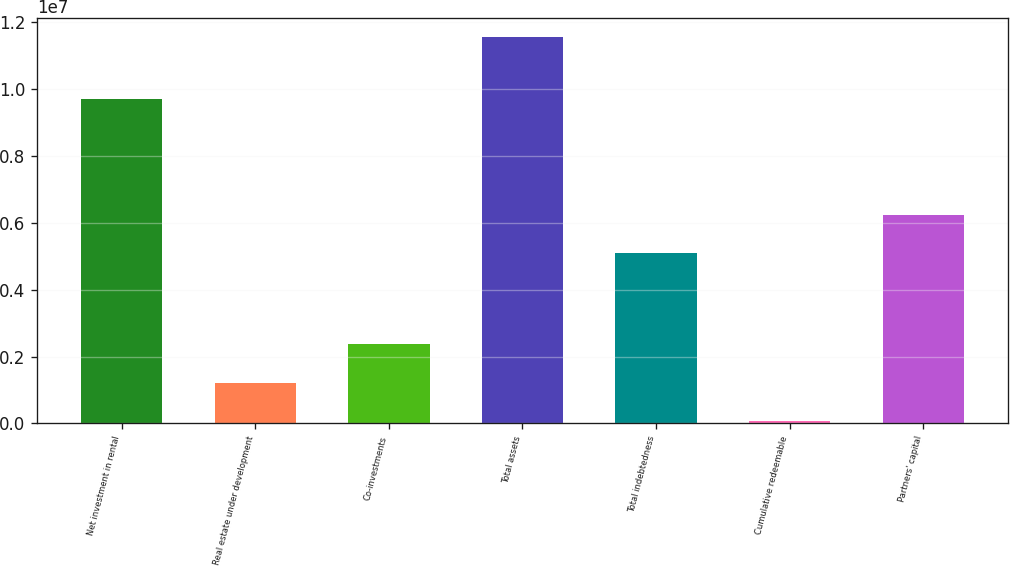Convert chart to OTSL. <chart><loc_0><loc_0><loc_500><loc_500><bar_chart><fcel>Net investment in rental<fcel>Real estate under development<fcel>Co-investments<fcel>Total assets<fcel>Total indebtedness<fcel>Cumulative redeemable<fcel>Partners' capital<nl><fcel>9.67988e+06<fcel>1.21676e+06<fcel>2.36231e+06<fcel>1.15267e+07<fcel>5.08069e+06<fcel>71209<fcel>6.22624e+06<nl></chart> 